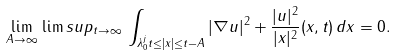Convert formula to latex. <formula><loc_0><loc_0><loc_500><loc_500>\lim _ { A \to \infty } \, \lim s u p _ { t \to \infty } \, \int _ { \lambda _ { 0 } ^ { j } t \leq | x | \leq t - A } | \nabla u | ^ { 2 } + \frac { | u | ^ { 2 } } { | x | ^ { 2 } } ( x , t ) \, d x = 0 .</formula> 